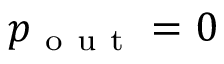<formula> <loc_0><loc_0><loc_500><loc_500>p _ { o u t } = 0</formula> 